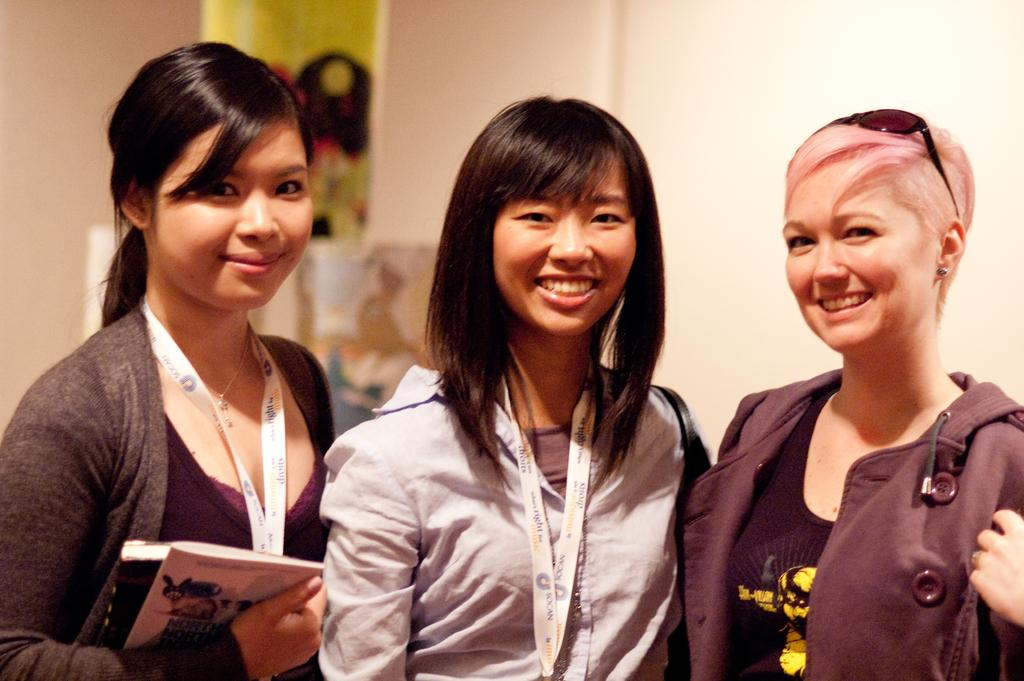What can be seen in the image? There are women standing in the image. Are there any specific details about the women's attire or accessories? Two women are wearing ID cards. What is one of the women holding in her hand? There is a woman holding books in her hand. Can you see a crown on any of the women's heads in the image? No, there is no crown visible on any of the women's heads in the image. 